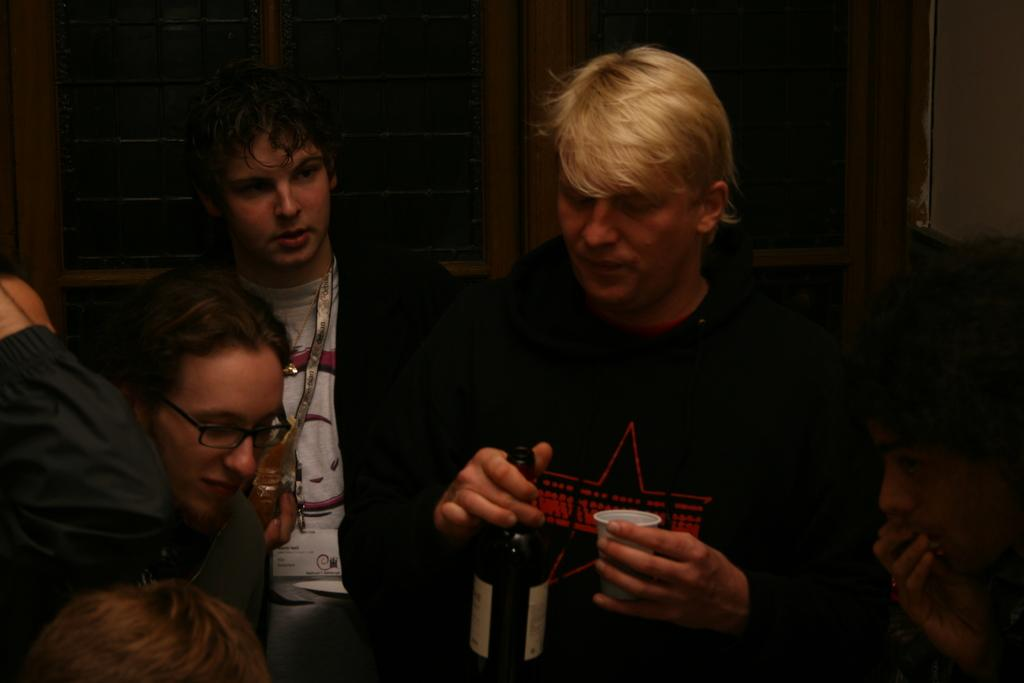How many people are in the image? There are people in the image. What is one person holding in the image? One person is holding a bottle and a cup. Can you describe any accessories worn by the people in the image? Another person is wearing glasses (specs). What can be seen in the background of the image? There are windows visible in the background of the image. Are there any animals, such as a cat, visible in the image? There is no cat or any other animal present in the image. What type of farm equipment can be seen in the image? There is no farm equipment present in the image. 